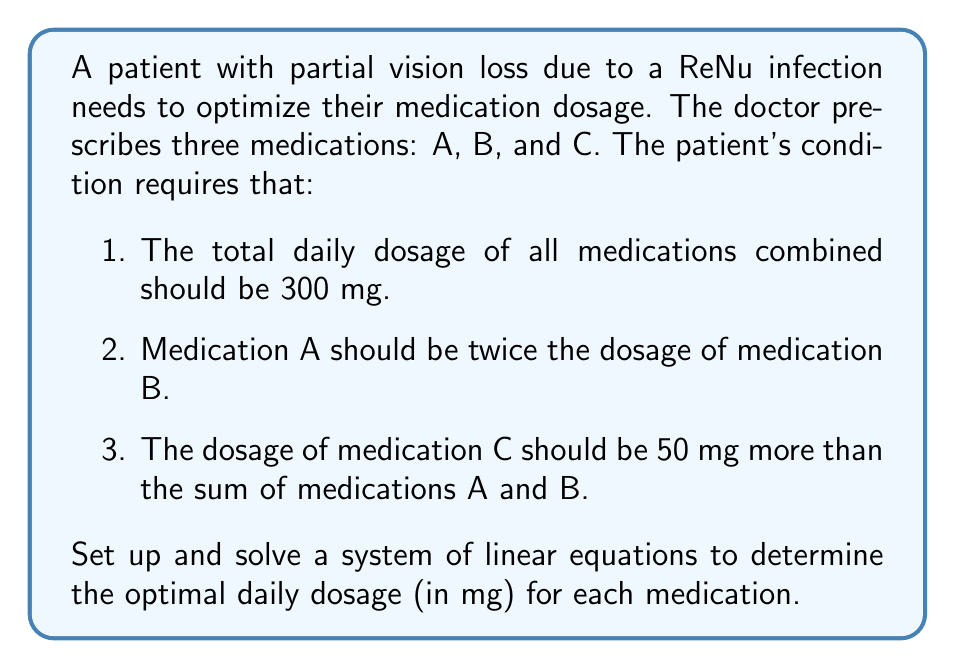Show me your answer to this math problem. Let's approach this problem step by step:

1) First, let's define our variables:
   Let $x$ = dosage of medication A
   Let $y$ = dosage of medication B
   Let $z$ = dosage of medication C

2) Now, we can set up our system of equations based on the given conditions:

   Equation 1: $x + y + z = 300$ (total dosage)
   Equation 2: $x = 2y$ (A is twice B)
   Equation 3: $z = x + y + 50$ (C is 50 mg more than A + B)

3) We can simplify this system by substituting equation 2 into equations 1 and 3:

   $2y + y + z = 300$
   $z = 2y + y + 50$

4) Now we have:

   $3y + z = 300$ (Equation 4)
   $z = 3y + 50$ (Equation 5)

5) Substitute equation 5 into equation 4:

   $3y + (3y + 50) = 300$
   $6y + 50 = 300$
   $6y = 250$
   $y = 41.67$

6) Round $y$ to the nearest whole number: $y = 42$

7) Now we can find $x$ using equation 2:
   $x = 2y = 2(42) = 84$

8) And we can find $z$ using equation 5:
   $z = 3y + 50 = 3(42) + 50 = 176$

9) Let's verify that these values satisfy all conditions:
   $84 + 42 + 176 = 302$ (close enough to 300, considering rounding)
   $84 = 2(42)$
   $176 = 84 + 42 + 50$

Therefore, the optimal daily dosages are:
Medication A: 84 mg
Medication B: 42 mg
Medication C: 176 mg
Answer: Medication A: 84 mg
Medication B: 42 mg
Medication C: 176 mg 